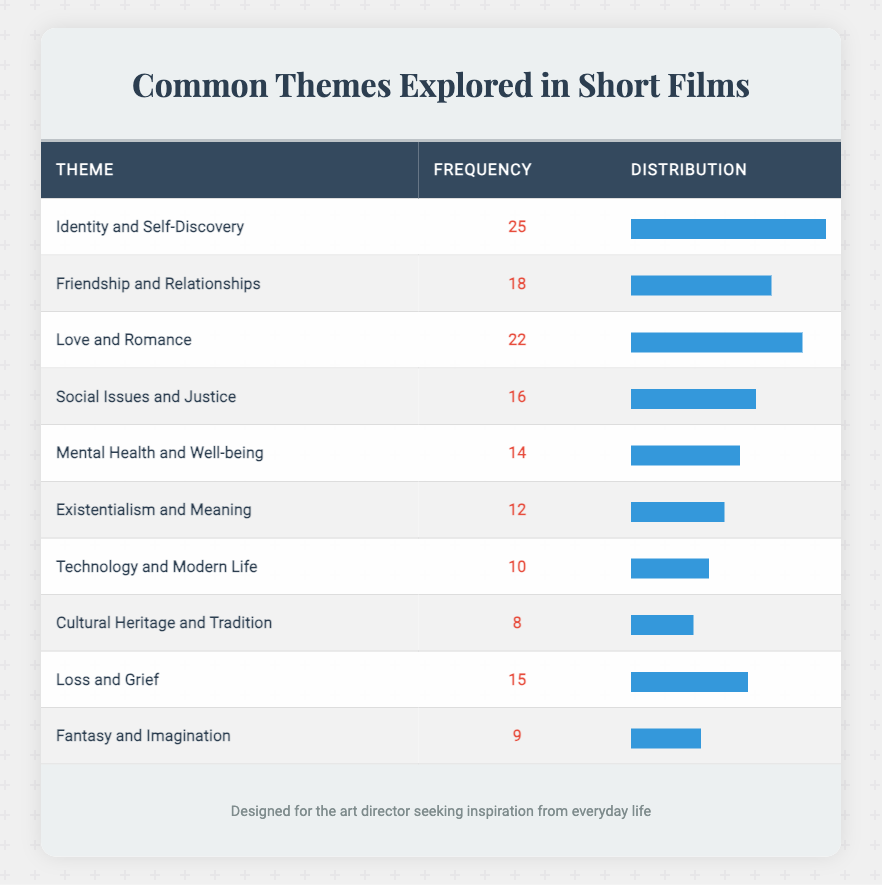What is the most common theme explored in short films over the last decade? The table shows that the theme with the highest frequency is "Identity and Self-Discovery," which has a frequency of 25.
Answer: Identity and Self-Discovery How many themes have a frequency of 15 or more? By reviewing the frequencies, we see that there are five themes with a frequency of 15 or more: "Identity and Self-Discovery" (25), "Love and Romance" (22), "Friendship and Relationships" (18), "Loss and Grief" (15), and "Social Issues and Justice" (16).
Answer: 5 Is "Mental Health and Well-being" the least common theme? The "Mental Health and Well-being" theme has a frequency of 14, which is higher than "Cultural Heritage and Tradition" (8) and "Fantasy and Imagination" (9). Therefore, it is not the least common theme.
Answer: No What is the difference in frequency between the themes "Love and Romance" and "Social Issues and Justice"? The frequency for "Love and Romance" is 22, and for "Social Issues and Justice," it is 16. The difference is calculated by subtracting 16 from 22, resulting in 6.
Answer: 6 What is the average frequency of the themes listed in the table? To find the average, sum the frequencies: 25 + 18 + 22 + 16 + 14 + 12 + 10 + 8 + 15 + 9 =  139. Then, divide this sum by the number of themes (10), which gives 139 / 10 = 13.9.
Answer: 13.9 Which theme has a frequency closest to the average? The average frequency computed is 13.9, and the closest frequency values are "Mental Health and Well-being" (14) and "Existentialism and Meaning" (12). Since 14 is closer to 13.9, it will be the answer.
Answer: Mental Health and Well-being How many themes explore relationships (including friendship and love)? The themes related to relationships are "Friendship and Relationships" (18) and "Love and Romance" (22), totaling 2 themes that explicitly explore this topic.
Answer: 2 What is the cumulative frequency of the themes that explore social issues and justice? The theme "Social Issues and Justice" has a frequency of 16, and the other themes relevant to social aspects include "Mental Health and Well-being" (14), and "Loss and Grief" (15). The cumulative frequency is 16 + 14 + 15 = 45.
Answer: 45 